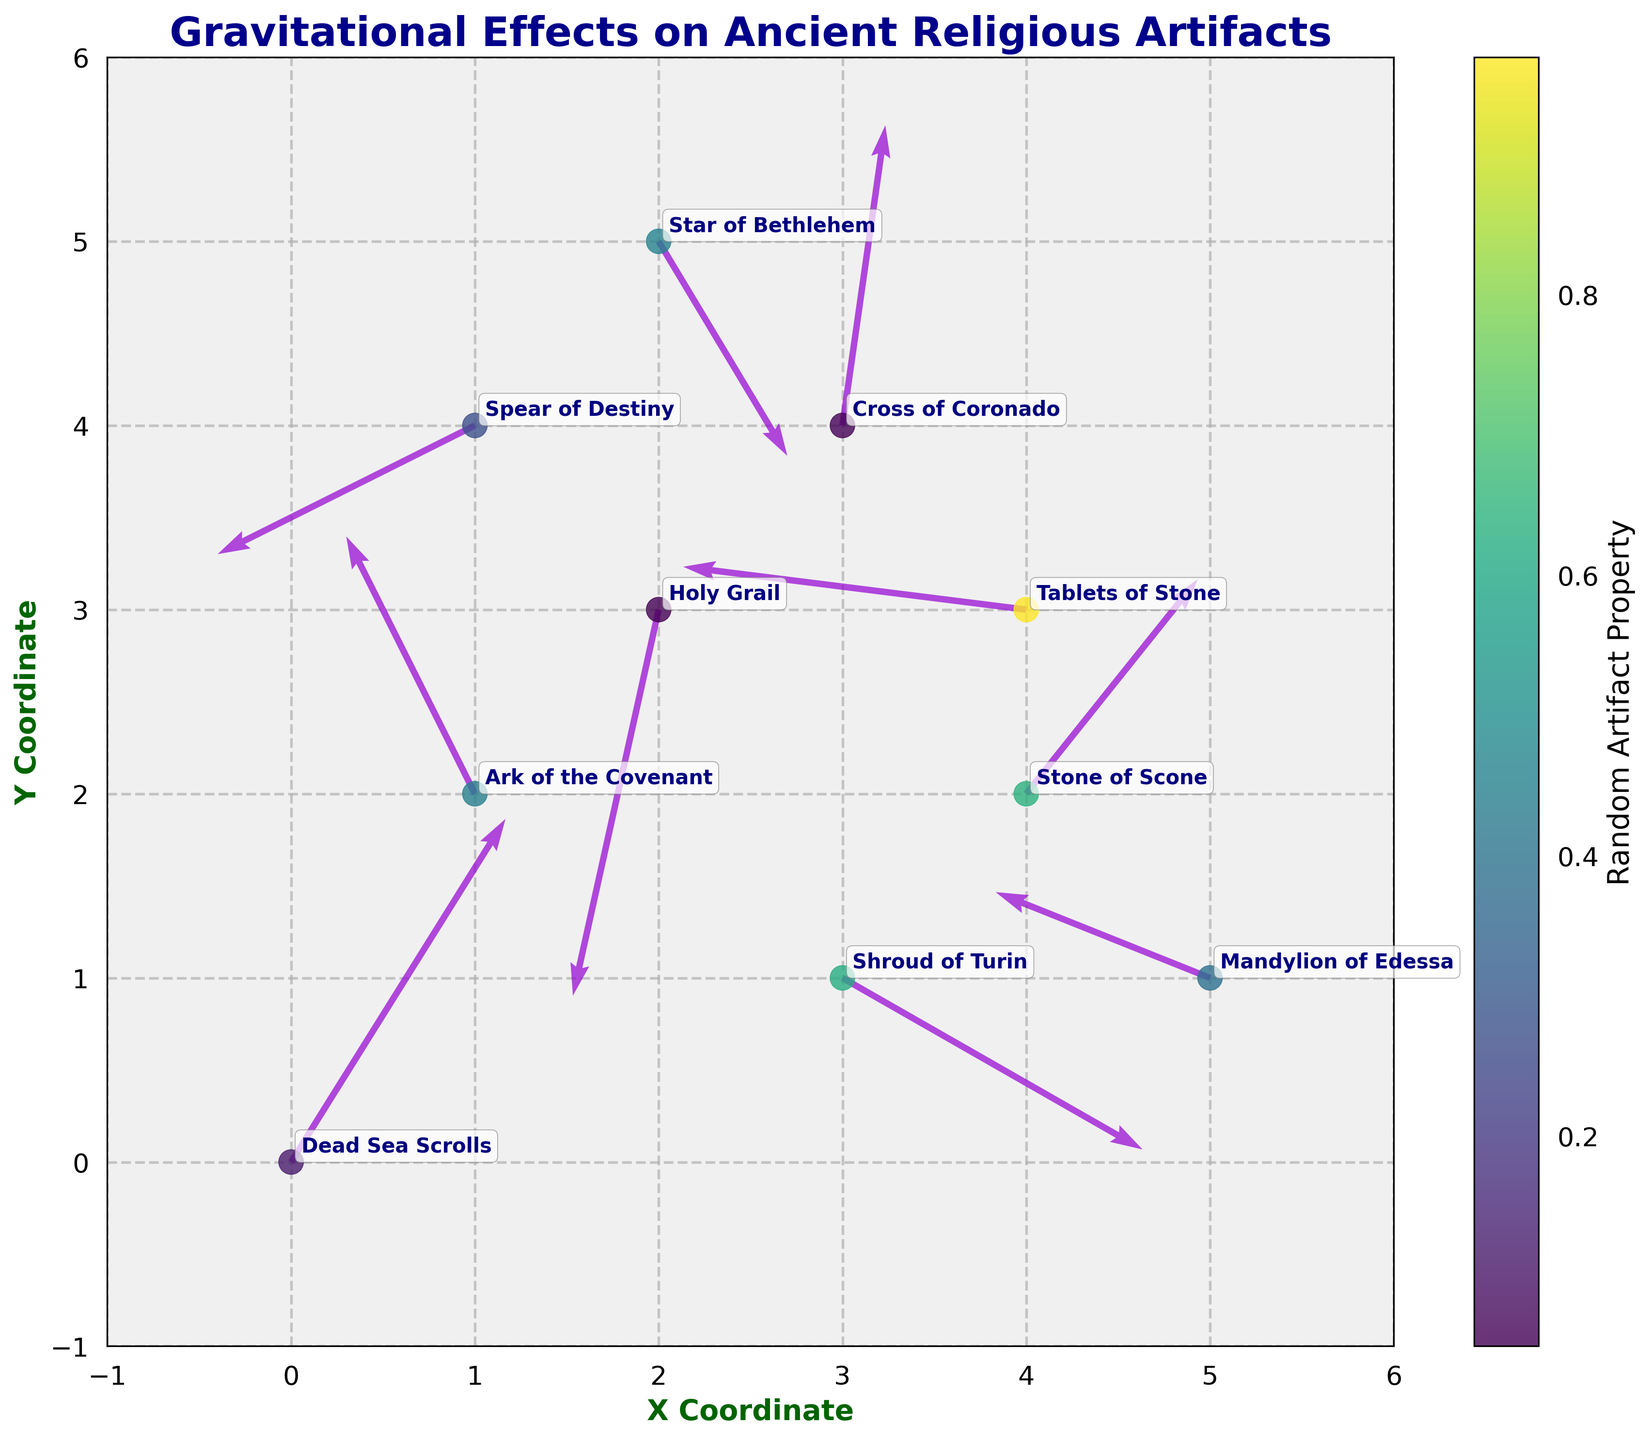What is the title of the figure? The title of the figure is usually displayed at the top of the plot, and in this case, it reads "Gravitational Effects on Ancient Religious Artifacts."
Answer: Gravitational Effects on Ancient Religious Artifacts What does the X-axis represent? By examining the labels on the plot, we can see that the X-axis is labeled "X Coordinate," which represents the horizontal position of the data points.
Answer: X Coordinate How many data points are there in the plot? By counting the number of arrows or data points with labels on the plot, we can see that there are 10.
Answer: 10 Which artifact is located at the coordinates (1, 2)? By referring to the annotations on the plot, we can identify the artifact located at (1, 2) as the "Ark of the Covenant."
Answer: Ark of the Covenant Which artifact has the largest downward force (negative y-component of vector)? To find the artifact with the largest downward force, we scan for the largest negative value in the y-components of the vectors. The "Holy Grail" has the largest downward y-component of -0.9.
Answer: Holy Grail What is the color of the Cross of Coronado's data point? By observing the plot and identifying the actual point labeled "Cross of Coronado," we refer to the color bar, which associates numerical values with colors. The Cross of Coronado is likely colored in a shade close to turquoise or green as indicated by the viridis colormap.
Answer: Greenish-turquoise Which artifact shows a predominantly leftward force (negative x-component of vector)? By examining the arrows pointing to the left, we can see that artifacts like the "Stone of Scone" and "Spear of Destiny" have significant negative x-components (-0.8 and -0.6 respectively). The "Stone of Scone" has the most prominent leftward force vector.
Answer: Stone of Scone What are the coordinates of the artifact with the largest horizontal force component (x-direction)? To find this, we look for the largest magnitude in the horizontal (x-direction) forces. The artifact with coordinates (0, 0) has a force vector of (0.5, 0.8), making the x-component the largest at 0.5.
Answer: (0, 0) Is the vector associated with the "Shroud of Turin" pointing upwards or downwards? By studying the direction of the vector at coordinates (3, 1) associated with the "Shroud of Turin," we see that it points downward due to the negative y-component (-0.4).
Answer: Downwards 